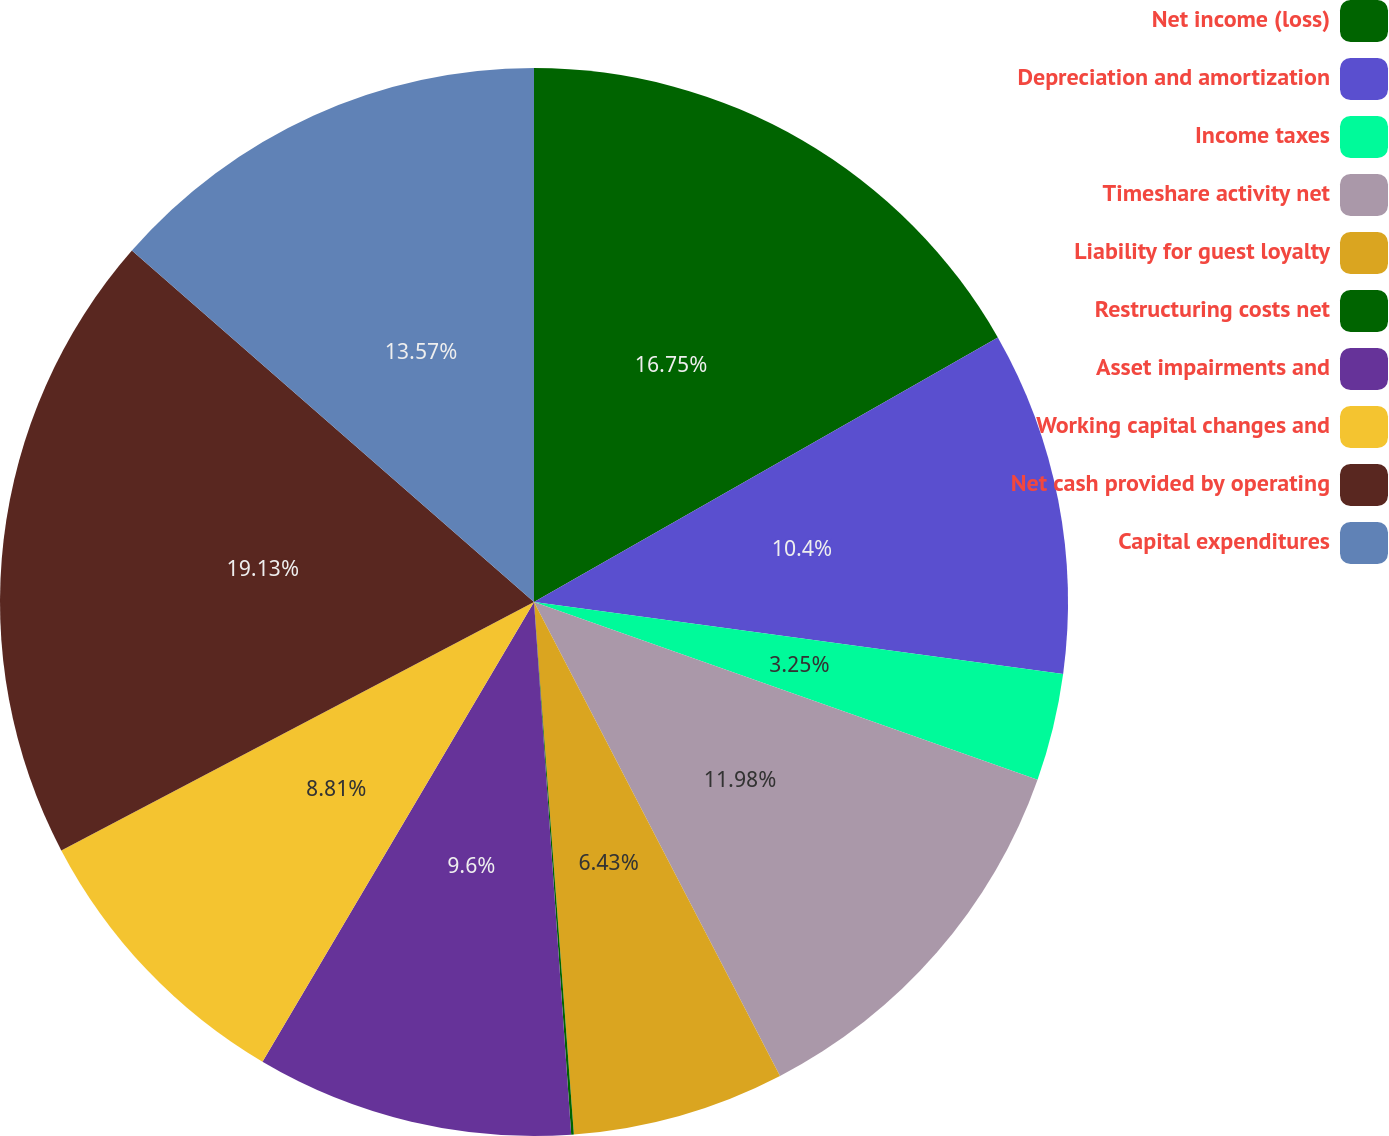<chart> <loc_0><loc_0><loc_500><loc_500><pie_chart><fcel>Net income (loss)<fcel>Depreciation and amortization<fcel>Income taxes<fcel>Timeshare activity net<fcel>Liability for guest loyalty<fcel>Restructuring costs net<fcel>Asset impairments and<fcel>Working capital changes and<fcel>Net cash provided by operating<fcel>Capital expenditures<nl><fcel>16.75%<fcel>10.4%<fcel>3.25%<fcel>11.98%<fcel>6.43%<fcel>0.08%<fcel>9.6%<fcel>8.81%<fcel>19.13%<fcel>13.57%<nl></chart> 